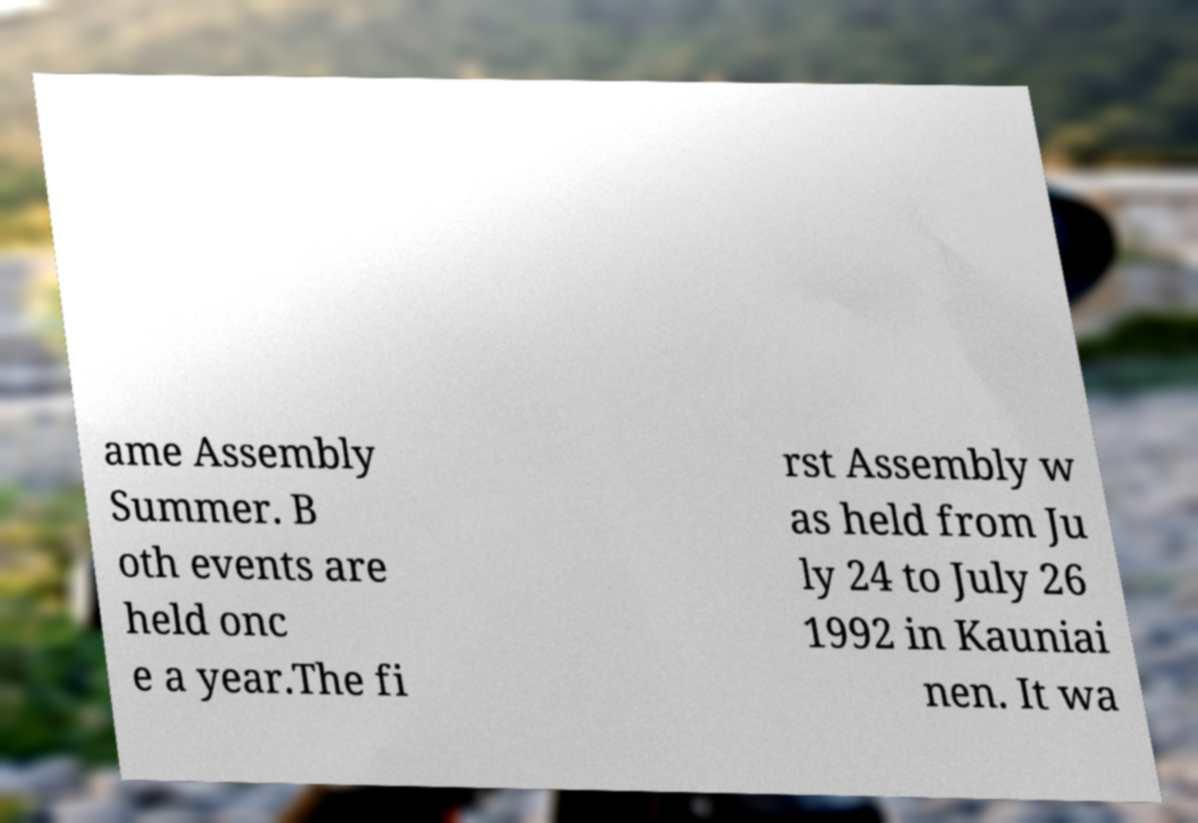What messages or text are displayed in this image? I need them in a readable, typed format. ame Assembly Summer. B oth events are held onc e a year.The fi rst Assembly w as held from Ju ly 24 to July 26 1992 in Kauniai nen. It wa 